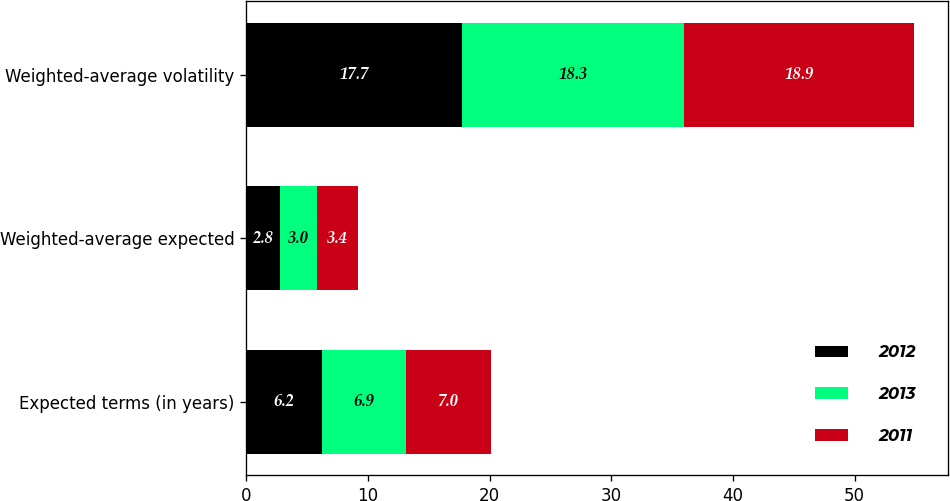Convert chart. <chart><loc_0><loc_0><loc_500><loc_500><stacked_bar_chart><ecel><fcel>Expected terms (in years)<fcel>Weighted-average expected<fcel>Weighted-average volatility<nl><fcel>2012<fcel>6.2<fcel>2.8<fcel>17.7<nl><fcel>2013<fcel>6.9<fcel>3<fcel>18.3<nl><fcel>2011<fcel>7<fcel>3.4<fcel>18.9<nl></chart> 